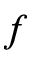<formula> <loc_0><loc_0><loc_500><loc_500>f</formula> 